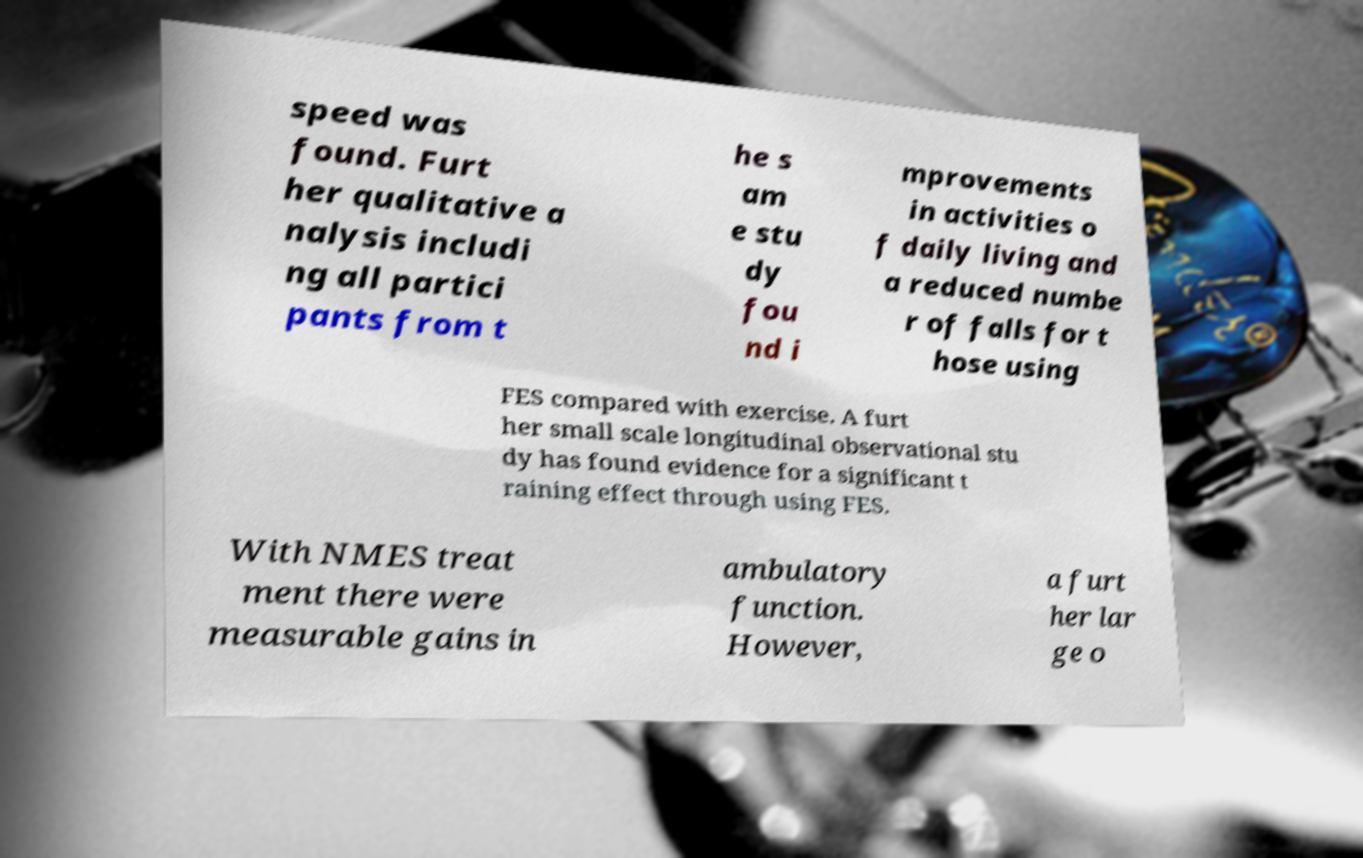For documentation purposes, I need the text within this image transcribed. Could you provide that? speed was found. Furt her qualitative a nalysis includi ng all partici pants from t he s am e stu dy fou nd i mprovements in activities o f daily living and a reduced numbe r of falls for t hose using FES compared with exercise. A furt her small scale longitudinal observational stu dy has found evidence for a significant t raining effect through using FES. With NMES treat ment there were measurable gains in ambulatory function. However, a furt her lar ge o 